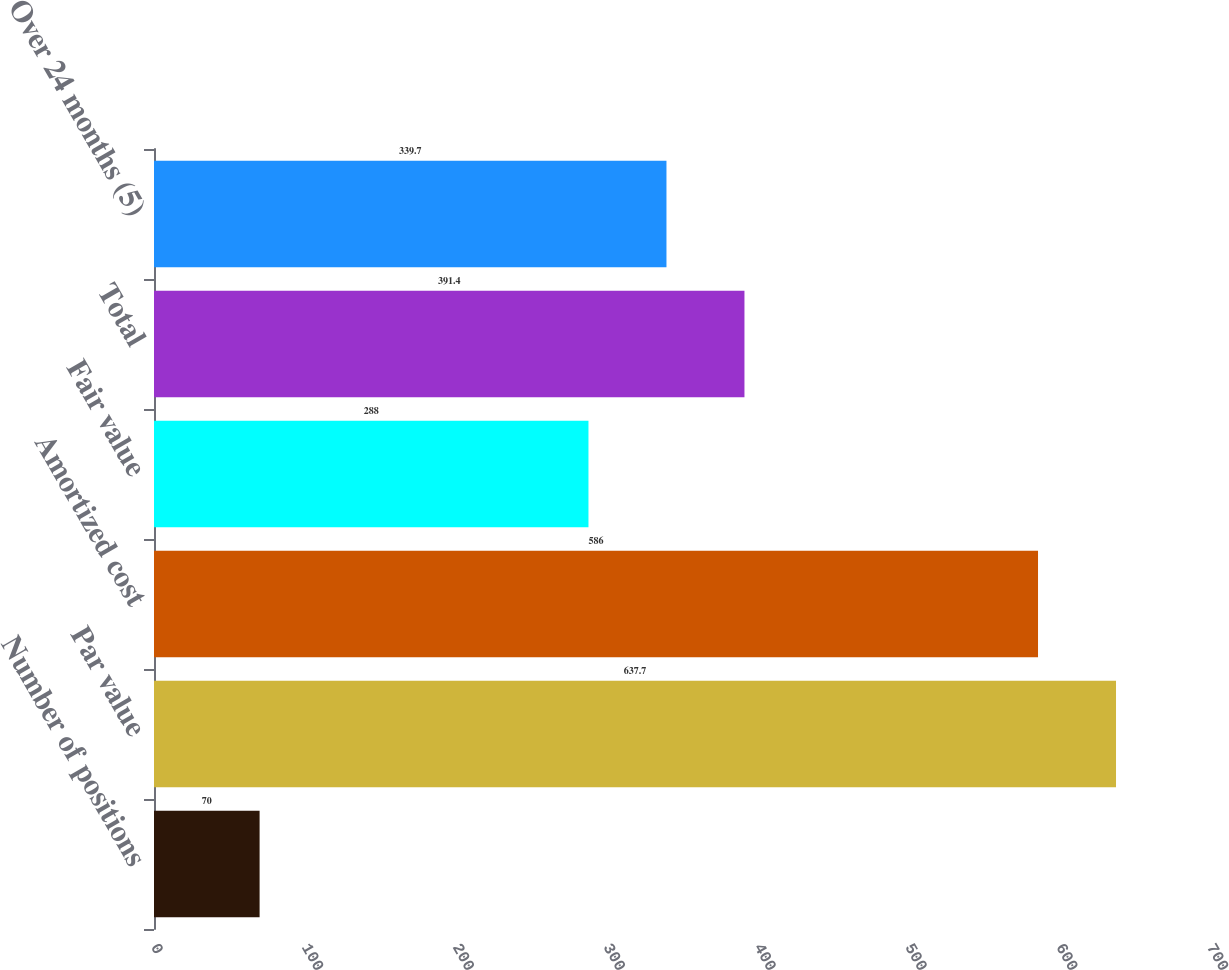Convert chart. <chart><loc_0><loc_0><loc_500><loc_500><bar_chart><fcel>Number of positions<fcel>Par value<fcel>Amortized cost<fcel>Fair value<fcel>Total<fcel>Over 24 months (5)<nl><fcel>70<fcel>637.7<fcel>586<fcel>288<fcel>391.4<fcel>339.7<nl></chart> 